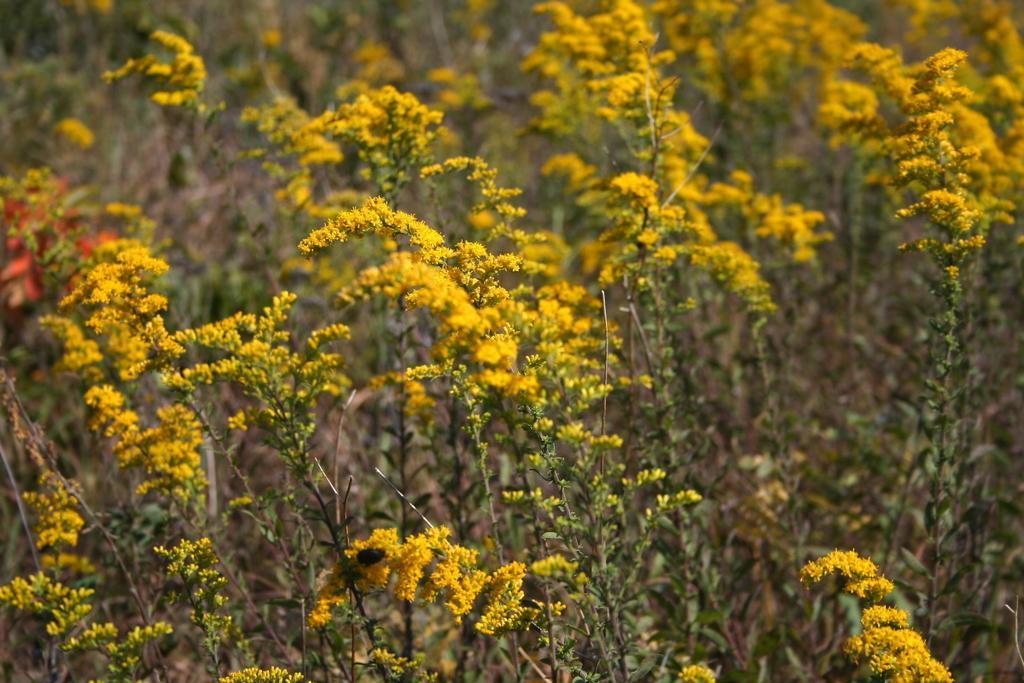Describe this image in one or two sentences. This picture contains plants which are flowering and these flowers are in yellow color. In the background, it is blurred. This picture might be clicked in the garden. 